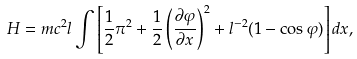Convert formula to latex. <formula><loc_0><loc_0><loc_500><loc_500>H = m { c } ^ { 2 } l \int { \left [ \frac { 1 } { 2 } \pi ^ { 2 } + \frac { 1 } { 2 } \left ( \frac { \partial \varphi } { \partial x } \right ) ^ { 2 } + l ^ { - 2 } ( 1 - \cos \varphi ) \right ] d x } ,</formula> 